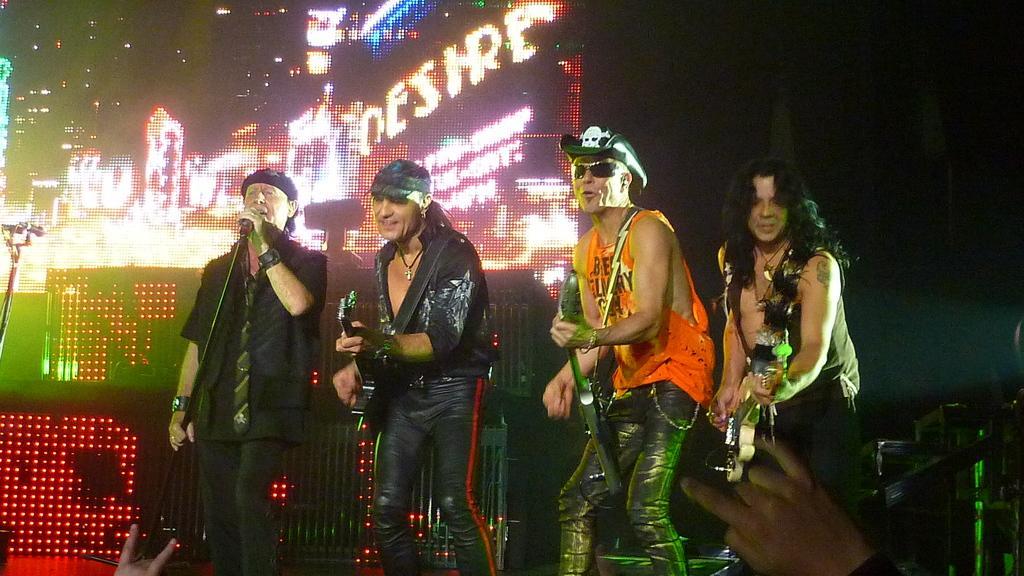Describe this image in one or two sentences. This picture is clicked at a stage performance ,there are four people performing. On the right there is a man he is playing guitar. In the left there is a man he is singing. In the background there is a big screen. 